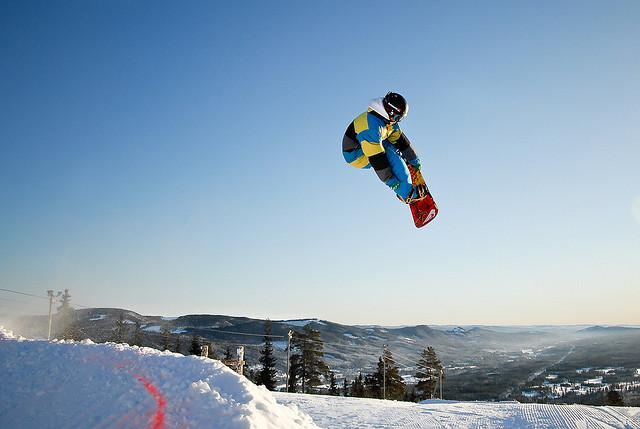Is this a competition?
Write a very short answer. Yes. Are there any visible spectators?
Answer briefly. No. What is this sport?
Keep it brief. Snowboarding. 